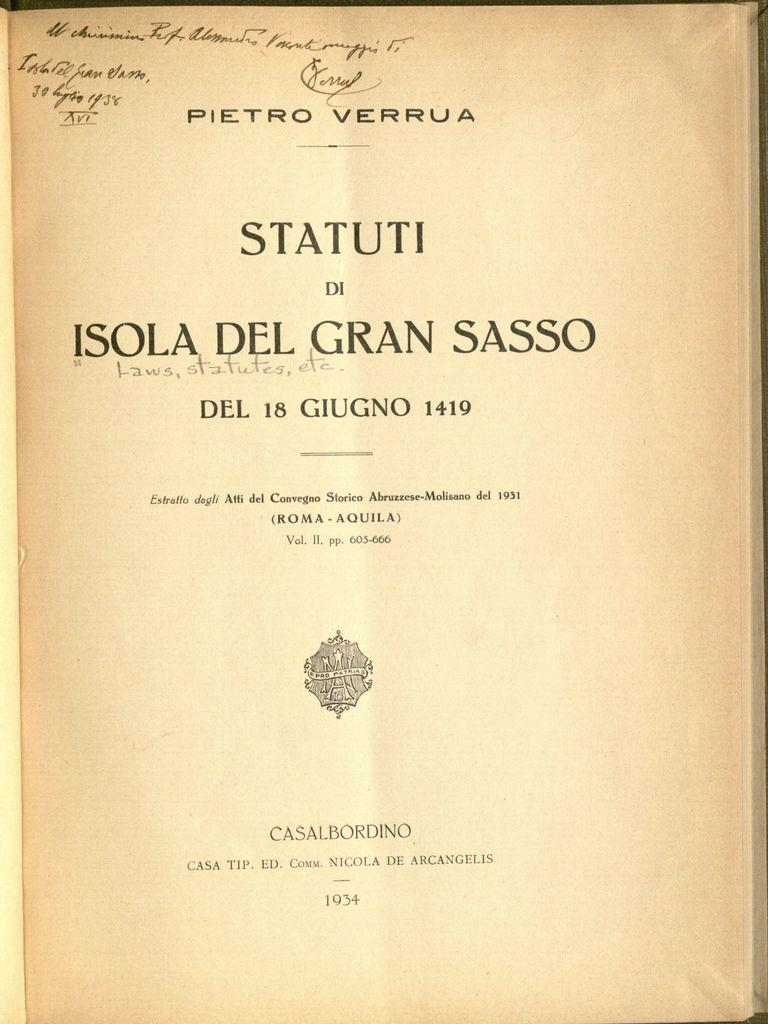Provide a one-sentence caption for the provided image. A book written in Italian open to its title page. 